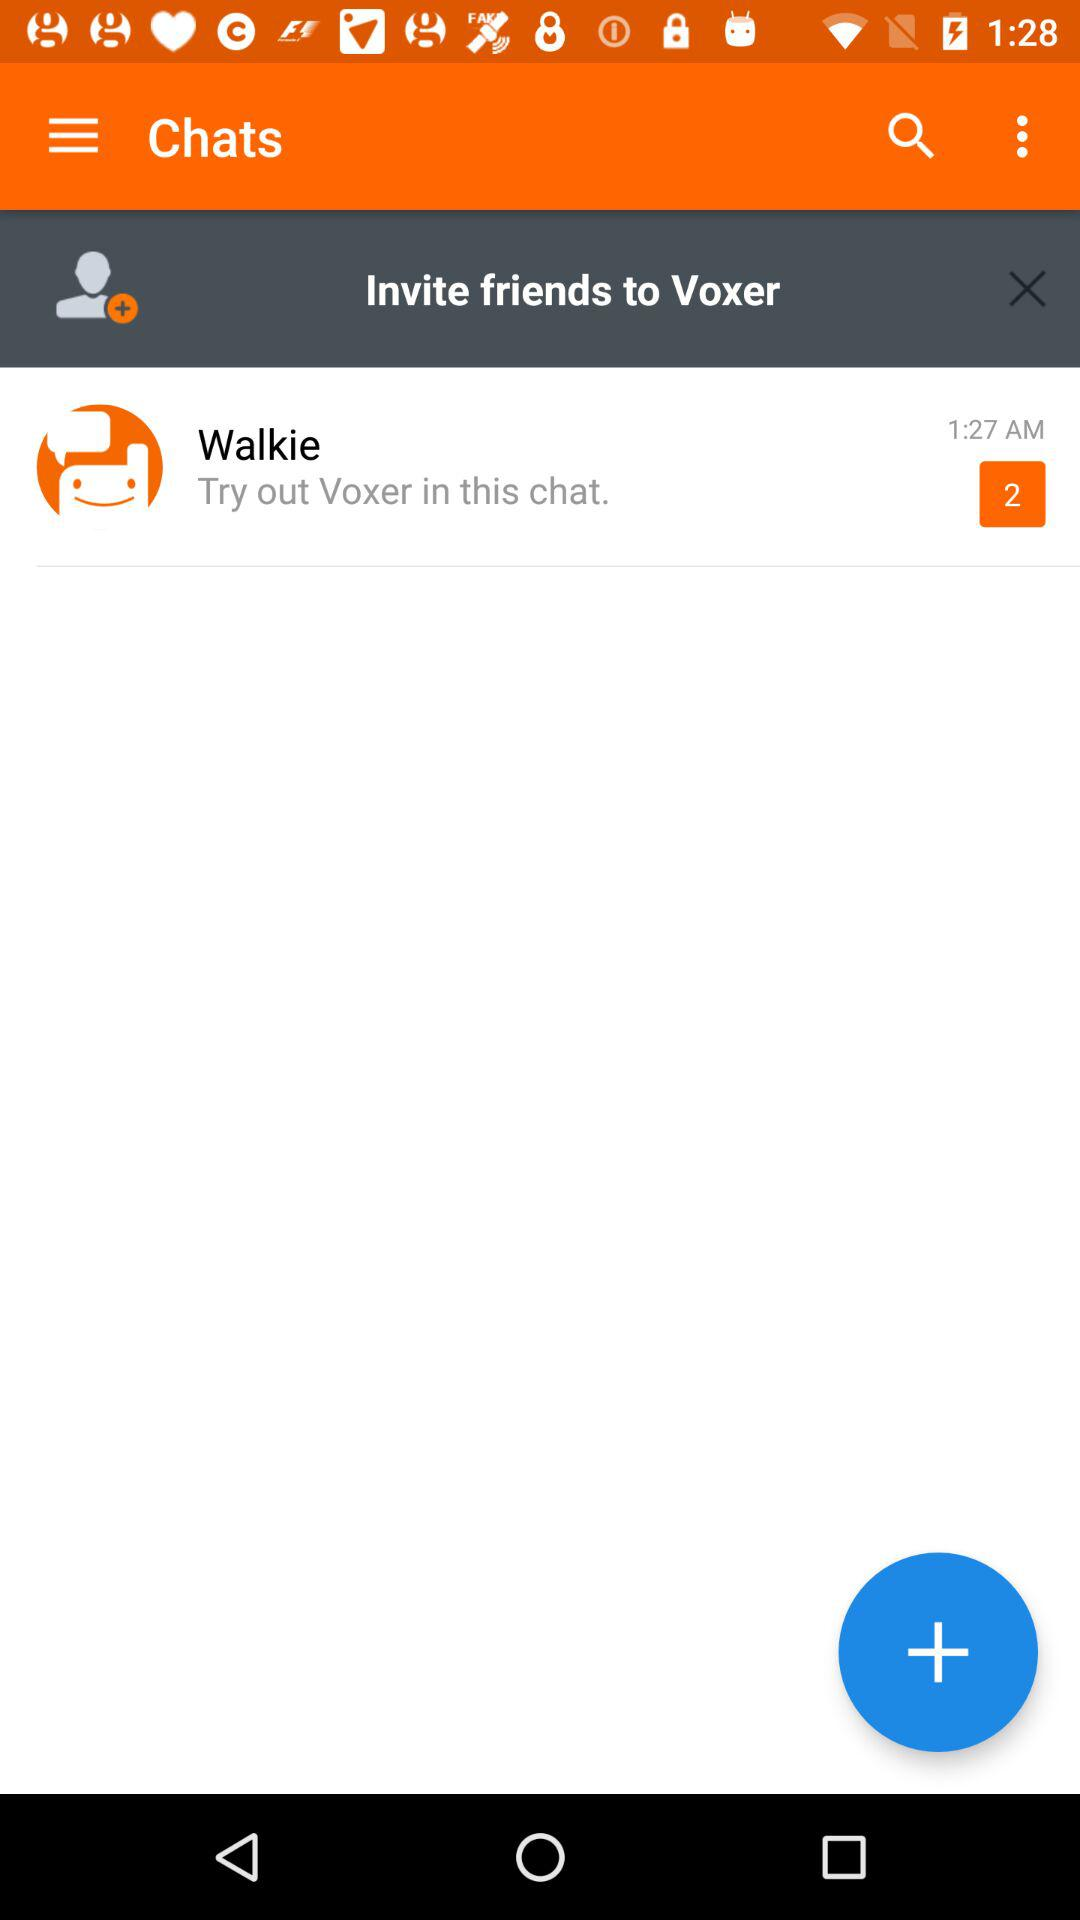How many more conversations are there than friends?
Answer the question using a single word or phrase. 1 